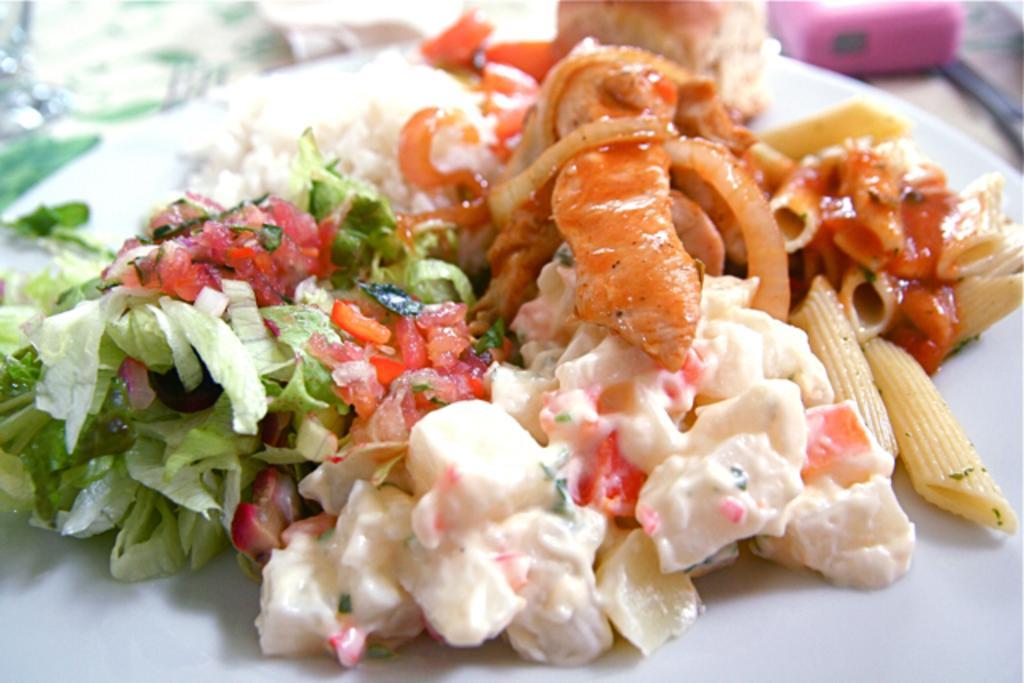Please provide a concise description of this image. In this image I can see food which is in white, red, green color in the plate and the plate is in white color. 